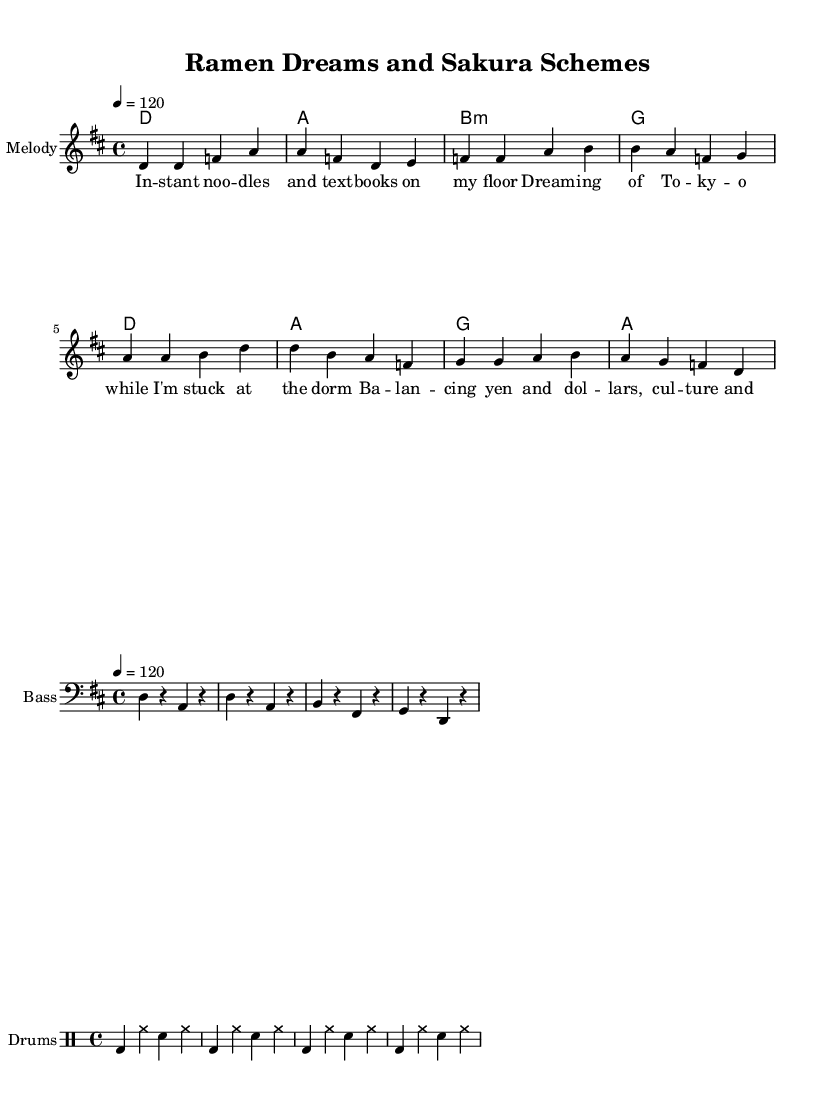What is the key signature of this music? The key signature is indicated by the number of sharps or flats at the beginning of the staff. In this piece, there is an "F#" shown, so it is in D major.
Answer: D major What is the time signature of this music? The time signature is represented by the numbers at the start of the music. Here, the time signature is shown as "4/4," meaning there are four beats per measure.
Answer: 4/4 What is the tempo marking for this piece? Tempo markings indicate the speed of the music and are generally placed above the staff. In this piece, it is written as "4 = 120,” which means there are 120 beats per minute.
Answer: 120 How many measures are in the melody? To determine the number of measures in the melody, count the number of vertical lines (bar lines) present. The melody has 8 measures in total.
Answer: 8 What is the structure of the lyrics? The lyrics associated with the melody consist of four phrases, which can be identified by the separate lines of text. Each phrase corresponds directly to the melody notes.
Answer: Four phrases Which instrument is primarily featured in the score? The instrument name is shown at the beginning of the staff. Here it is labeled as "Melody," indicating that the primary instrument is a melody instrument, likely a lead instrument like guitar or piano.
Answer: Melody What rhythmic elements are included in the drum patterns? Look for the different drum symbols in the drum staff. The pattern includes bass drum, snare, and hi-hat, which are commonly used in rock music. This reveals a basic rock rhythm structure.
Answer: Bass drum, snare, hi-hat 